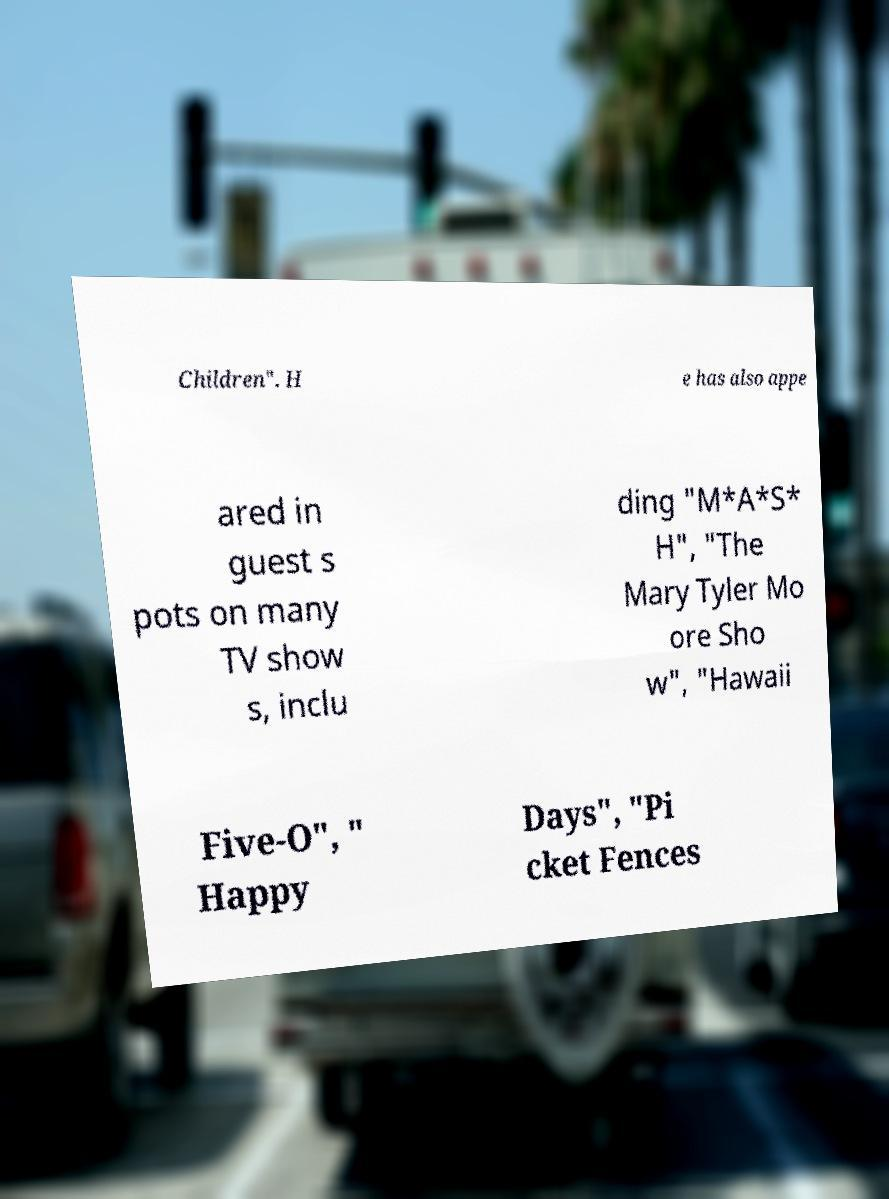There's text embedded in this image that I need extracted. Can you transcribe it verbatim? Children". H e has also appe ared in guest s pots on many TV show s, inclu ding "M*A*S* H", "The Mary Tyler Mo ore Sho w", "Hawaii Five-O", " Happy Days", "Pi cket Fences 